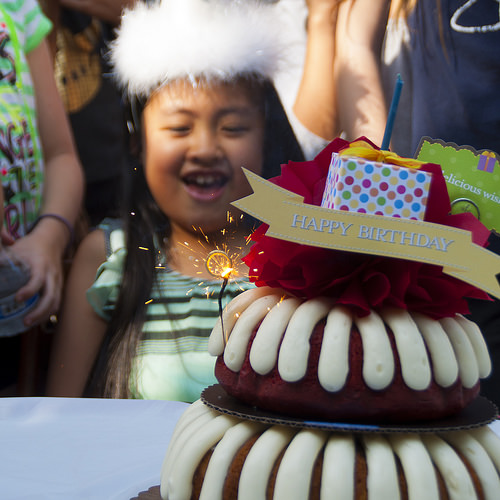<image>
Can you confirm if the chocolate is next to the human? Yes. The chocolate is positioned adjacent to the human, located nearby in the same general area. 